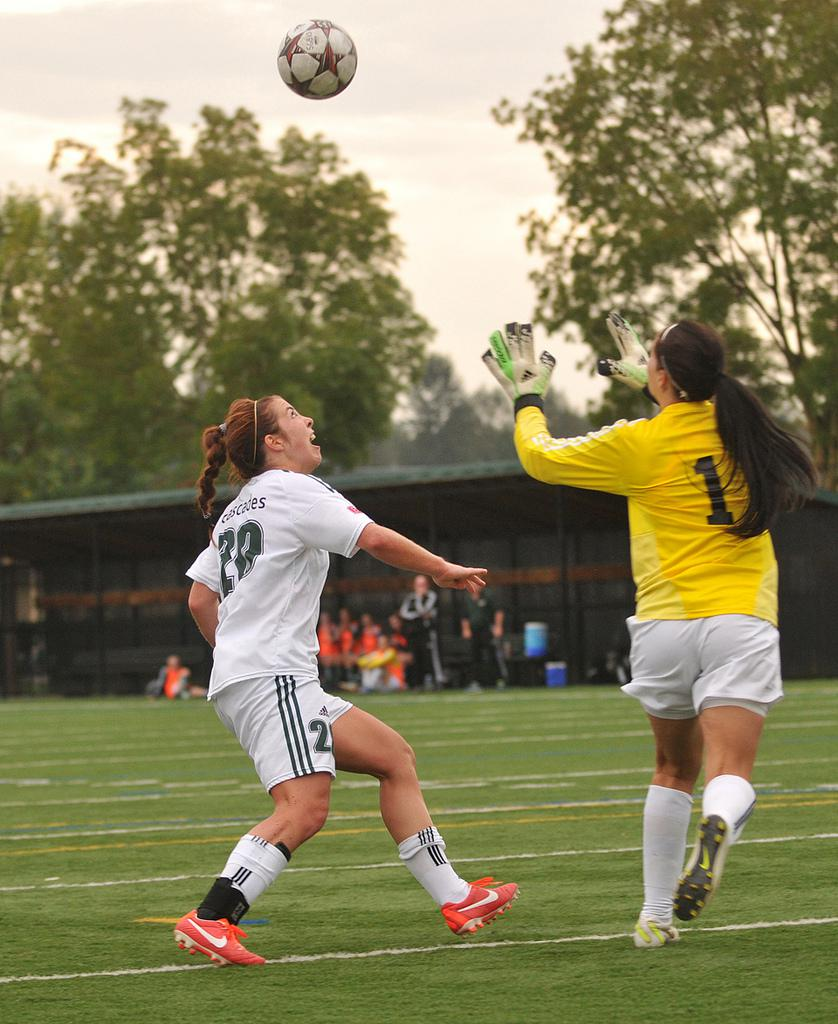Question: what are these girls doing?
Choices:
A. Swimming.
B. Eating.
C. Playing soccer.
D. Talking.
Answer with the letter. Answer: C Question: where was this picture taken?
Choices:
A. At a baseball game.
B. At a school.
C. On a soccer field.
D. At a computer show.
Answer with the letter. Answer: C Question: what color are the soccer player's shorts?
Choices:
A. Black.
B. Blue.
C. White.
D. Brown.
Answer with the letter. Answer: C Question: what is in the background?
Choices:
A. Trees.
B. The sky.
C. An ocean.
D. Mountains.
Answer with the letter. Answer: A Question: how many girls are playing volleyball?
Choices:
A. Four.
B. Two.
C. Six.
D. Eight.
Answer with the letter. Answer: B Question: who wears red and white shorts?
Choices:
A. Parents.
B. Coach.
C. Children.
D. Player.
Answer with the letter. Answer: D Question: what are the spectators under?
Choices:
A. An umbrella.
B. An awning.
C. A roof.
D. The sky.
Answer with the letter. Answer: C Question: what does one player have on her hands?
Choices:
A. Gloves.
B. Rings.
C. A tattoo.
D. Sun screen.
Answer with the letter. Answer: A Question: what has a star pattern?
Choices:
A. The american flag.
B. The ball.
C. A sign.
D. Someone's shirt.
Answer with the letter. Answer: B Question: what colors are the coolers?
Choices:
A. Red.
B. Blue.
C. White.
D. Green.
Answer with the letter. Answer: B Question: where is the ball?
Choices:
A. On the ground.
B. In the air.
C. In the net.
D. Aloft.
Answer with the letter. Answer: D Question: what color is the shirt on the girl on the right?
Choices:
A. Yellow.
B. Blue.
C. White.
D. Orange.
Answer with the letter. Answer: A Question: where are the spectators?
Choices:
A. In the stands.
B. On the lawn.
C. On the benches.
D. On the sidelines.
Answer with the letter. Answer: D Question: what do girls have on?
Choices:
A. Socks.
B. Bra.
C. Shoes.
D. Night gowns.
Answer with the letter. Answer: A Question: what are these girls looking at?
Choices:
A. A fish.
B. A boy.
C. A soccer ball.
D. A lake.
Answer with the letter. Answer: C Question: where are the stars?
Choices:
A. In the sky.
B. In Hollywood.
C. On the flag.
D. On the ball.
Answer with the letter. Answer: D Question: what are these players doing?
Choices:
A. Running.
B. Competing.
C. Huddling.
D. Fighting.
Answer with the letter. Answer: B Question: who is wearing knee socks?
Choices:
A. Men.
B. The women.
C. Children.
D. Both girls.
Answer with the letter. Answer: D 